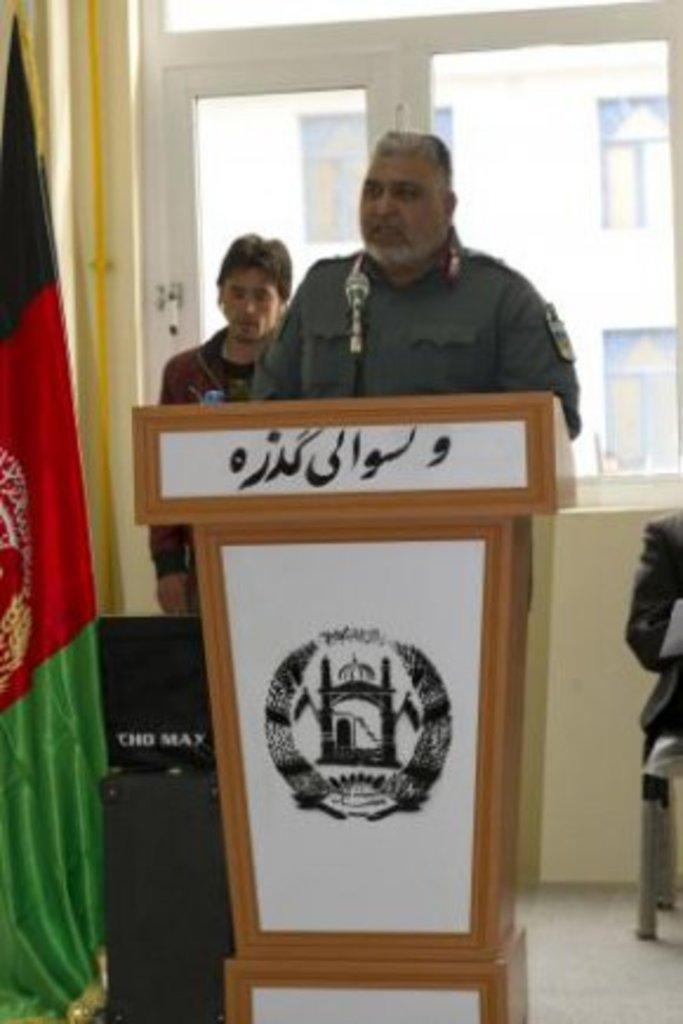Please provide a concise description of this image. In this picture we can see there are two people standing behind the podium and on the podium there is a logo and a microphone. On the left side of the podium there are black objects and a flag. On the right side of the podium, it looks like a person is sitting on a chair. Behind the people there is a wall with glass windows and behind the glass windows, we can see a building. 